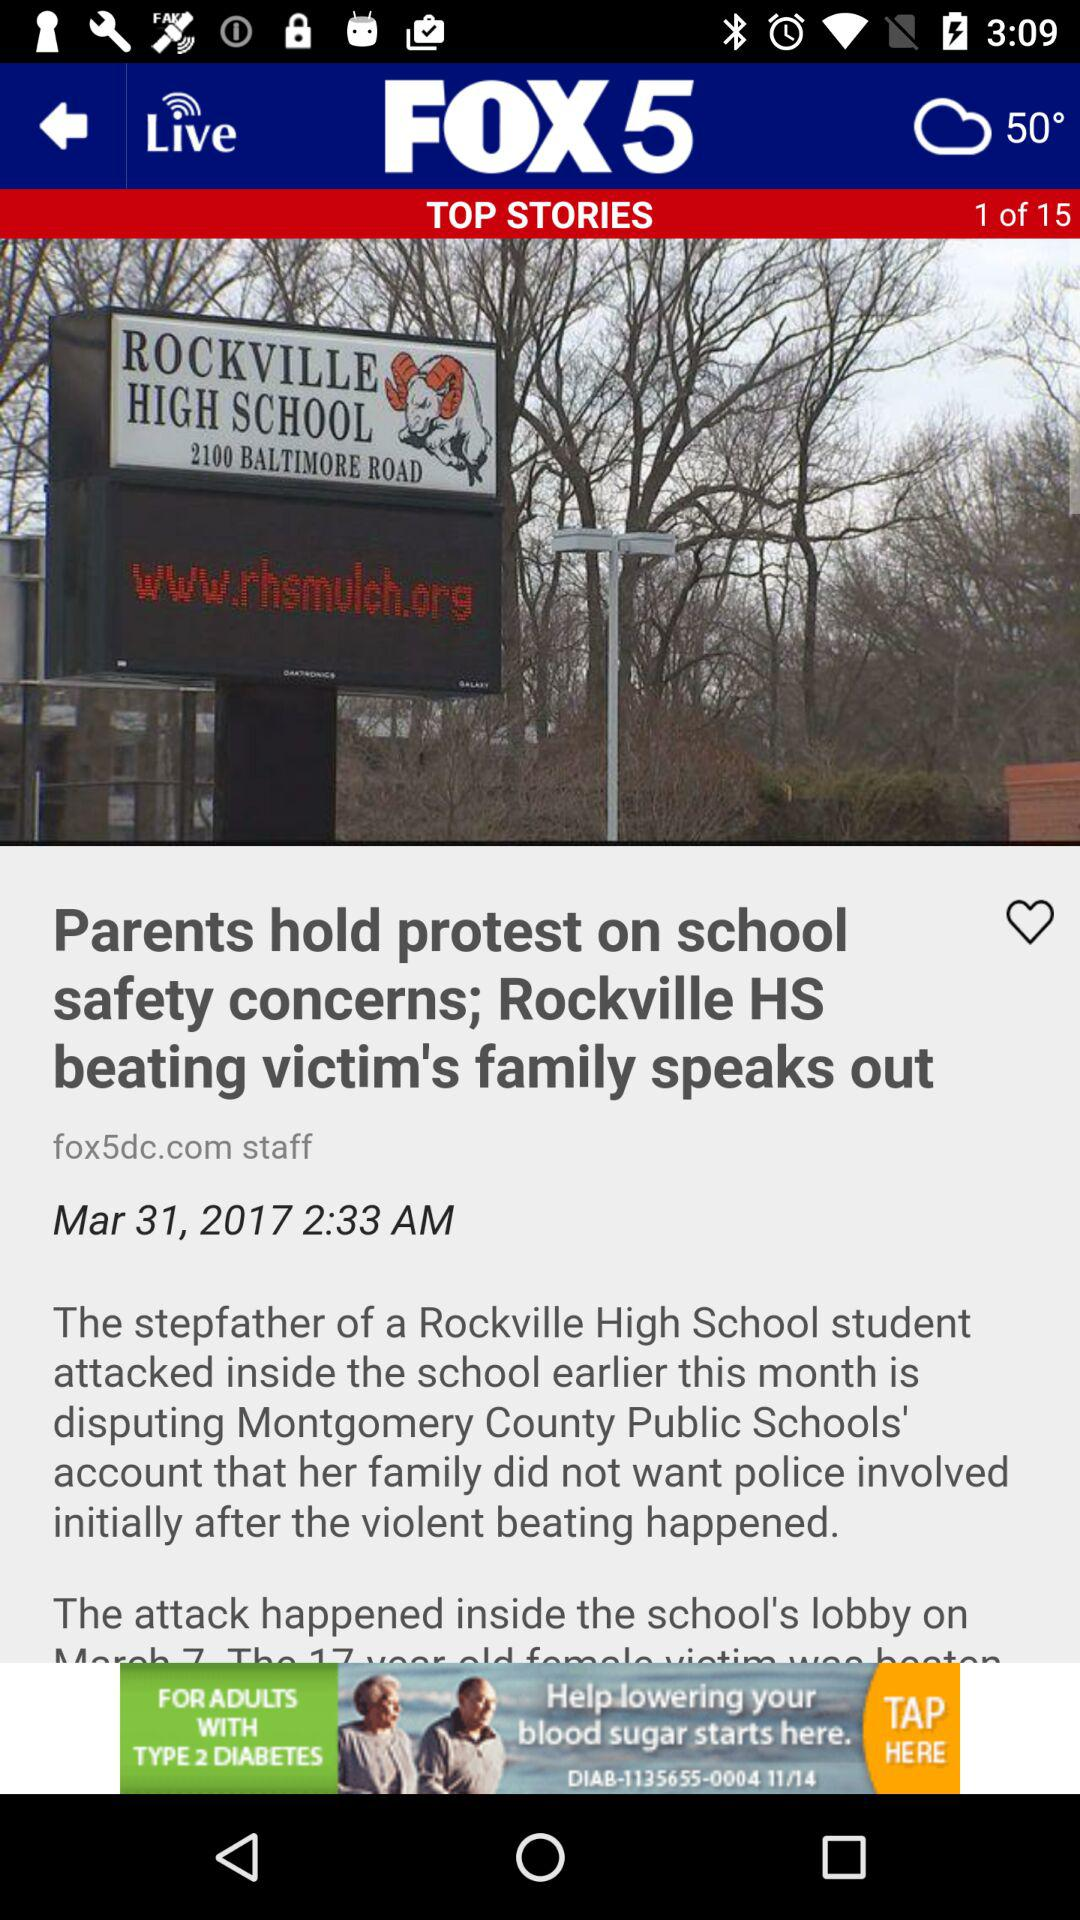How many total stories are there? There are 15 total stories. 